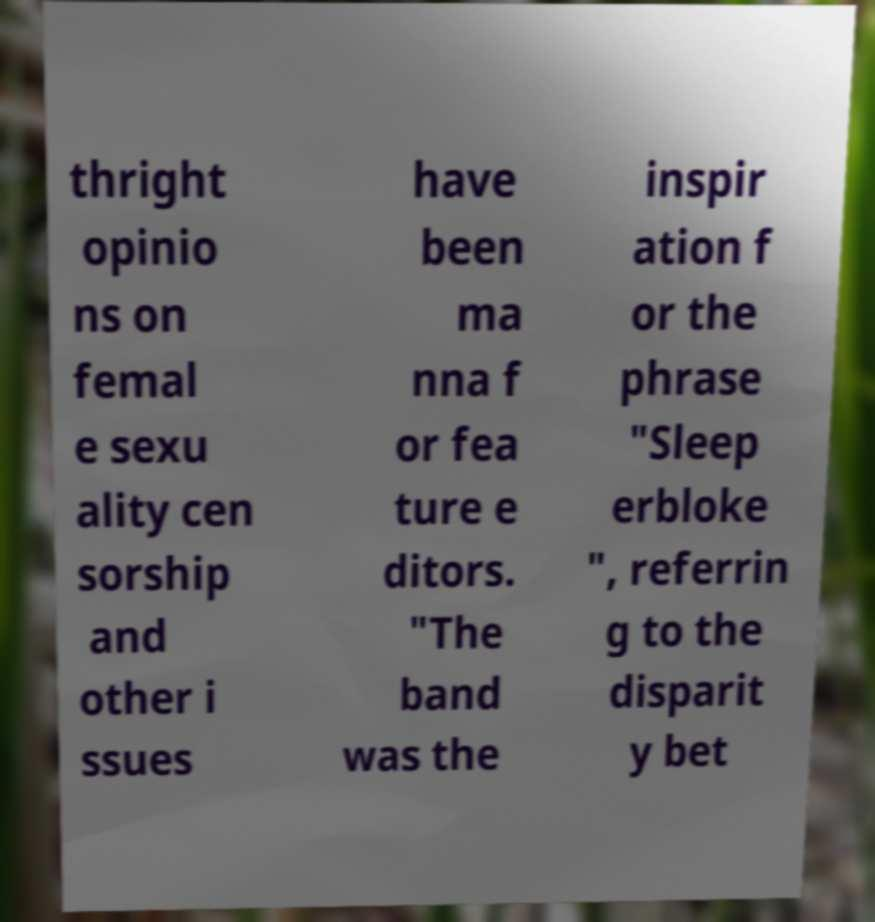Can you read and provide the text displayed in the image?This photo seems to have some interesting text. Can you extract and type it out for me? thright opinio ns on femal e sexu ality cen sorship and other i ssues have been ma nna f or fea ture e ditors. "The band was the inspir ation f or the phrase "Sleep erbloke ", referrin g to the disparit y bet 